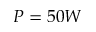<formula> <loc_0><loc_0><loc_500><loc_500>P = 5 0 W</formula> 